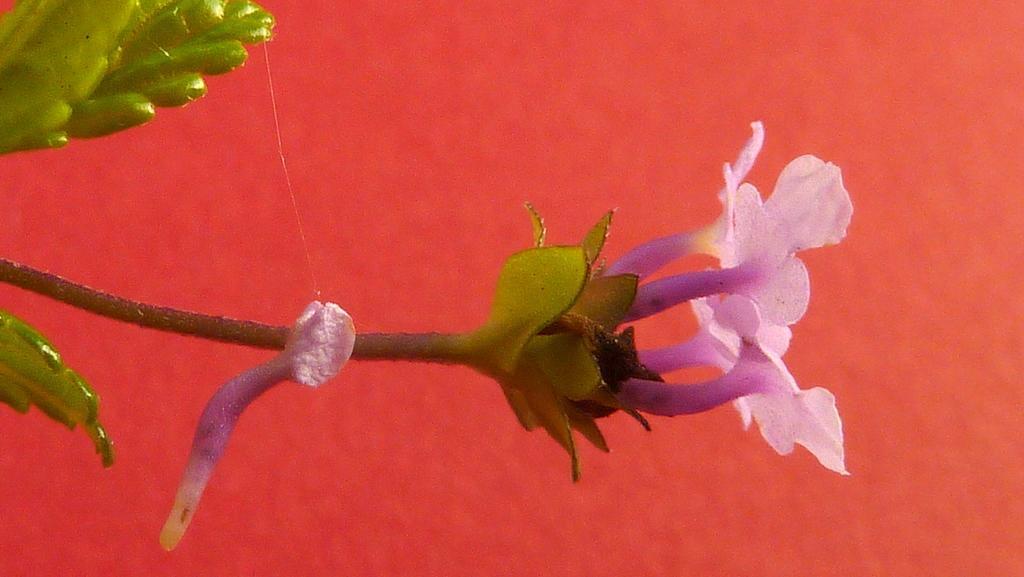Describe this image in one or two sentences. In this image I can see few flowers which are pink in color to a tree which is green in color and I can see the orange and red colored background. 